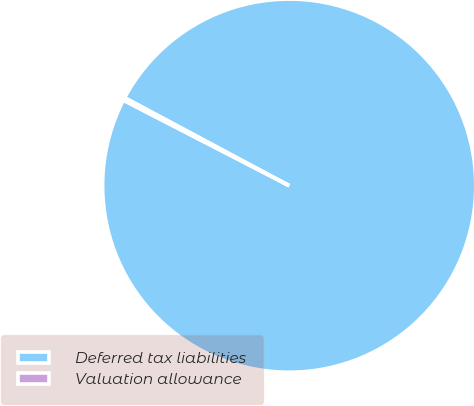<chart> <loc_0><loc_0><loc_500><loc_500><pie_chart><fcel>Deferred tax liabilities<fcel>Valuation allowance<nl><fcel>99.76%<fcel>0.24%<nl></chart> 